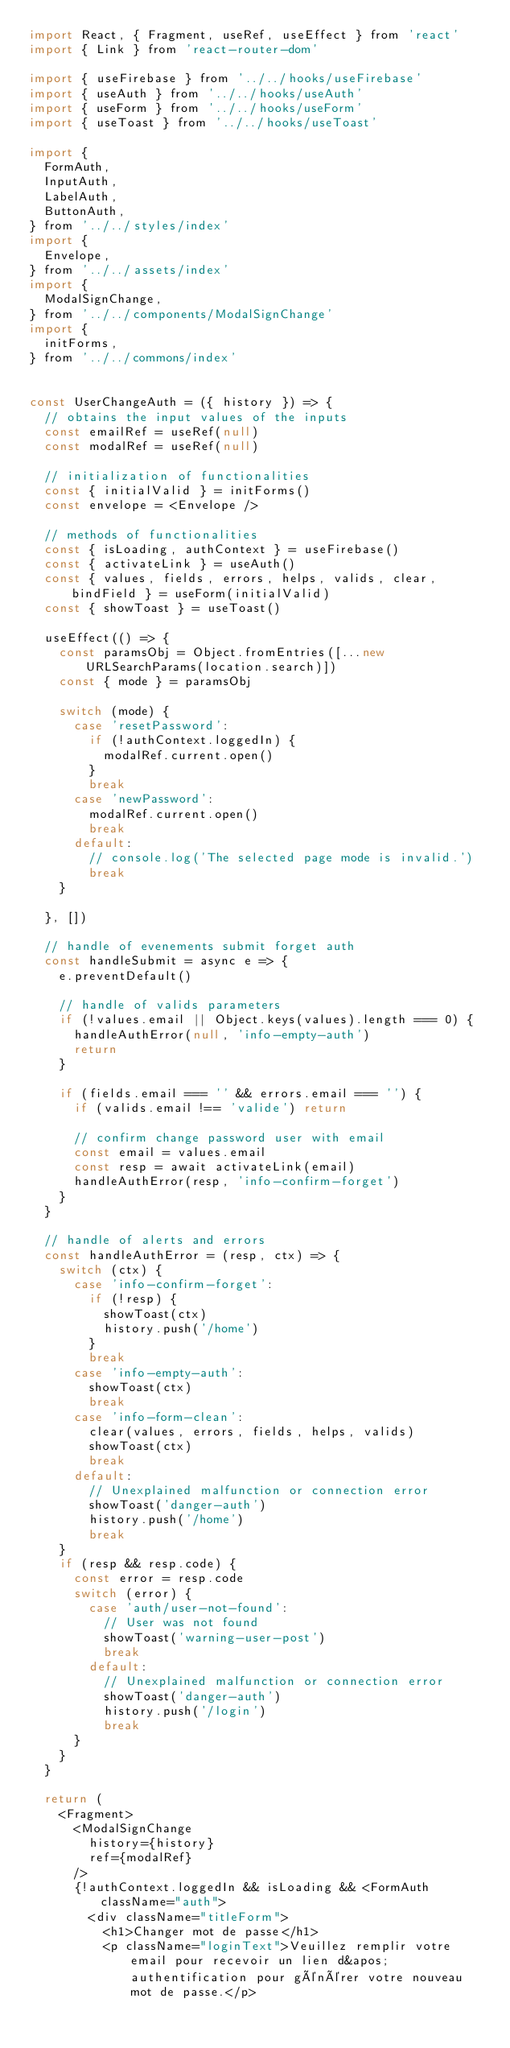<code> <loc_0><loc_0><loc_500><loc_500><_JavaScript_>import React, { Fragment, useRef, useEffect } from 'react'
import { Link } from 'react-router-dom'

import { useFirebase } from '../../hooks/useFirebase'
import { useAuth } from '../../hooks/useAuth'
import { useForm } from '../../hooks/useForm'
import { useToast } from '../../hooks/useToast'

import {
  FormAuth,
  InputAuth,
  LabelAuth,
  ButtonAuth,
} from '../../styles/index'
import {
  Envelope,
} from '../../assets/index'
import {
  ModalSignChange,
} from '../../components/ModalSignChange'
import {
  initForms,
} from '../../commons/index'


const UserChangeAuth = ({ history }) => {
  // obtains the input values of the inputs
  const emailRef = useRef(null)
  const modalRef = useRef(null)

  // initialization of functionalities
  const { initialValid } = initForms()
  const envelope = <Envelope />

  // methods of functionalities
  const { isLoading, authContext } = useFirebase()
  const { activateLink } = useAuth()
  const { values, fields, errors, helps, valids, clear, bindField } = useForm(initialValid)
  const { showToast } = useToast()

  useEffect(() => {
    const paramsObj = Object.fromEntries([...new URLSearchParams(location.search)])
    const { mode } = paramsObj

    switch (mode) {
      case 'resetPassword':
        if (!authContext.loggedIn) {
          modalRef.current.open()
        }
        break
      case 'newPassword':
        modalRef.current.open()
        break
      default:
        // console.log('The selected page mode is invalid.')
        break
    }

  }, [])

  // handle of evenements submit forget auth
  const handleSubmit = async e => {
    e.preventDefault()
 
    // handle of valids parameters
    if (!values.email || Object.keys(values).length === 0) {
      handleAuthError(null, 'info-empty-auth')
      return
    }

    if (fields.email === '' && errors.email === '') {
      if (valids.email !== 'valide') return

      // confirm change password user with email
      const email = values.email
      const resp = await activateLink(email)
      handleAuthError(resp, 'info-confirm-forget')
    }
  }

  // handle of alerts and errors
  const handleAuthError = (resp, ctx) => {
    switch (ctx) {
      case 'info-confirm-forget':
        if (!resp) {
          showToast(ctx)
          history.push('/home')
        }
        break
      case 'info-empty-auth':
        showToast(ctx)
        break
      case 'info-form-clean':
        clear(values, errors, fields, helps, valids)
        showToast(ctx)
        break
      default:
        // Unexplained malfunction or connection error
        showToast('danger-auth')
        history.push('/home')
        break
    }
    if (resp && resp.code) {
      const error = resp.code
      switch (error) {
        case 'auth/user-not-found':
          // User was not found
          showToast('warning-user-post')
          break
        default:
          // Unexplained malfunction or connection error
          showToast('danger-auth')
          history.push('/login')
          break
      }
    }
  }

  return (
    <Fragment>
      <ModalSignChange
        history={history}
        ref={modalRef}
      />
      {!authContext.loggedIn && isLoading && <FormAuth className="auth">
        <div className="titleForm">
          <h1>Changer mot de passe</h1>
          <p className="loginText">Veuillez remplir votre email pour recevoir un lien d&apos;authentification pour générer votre nouveau mot de passe.</p></code> 